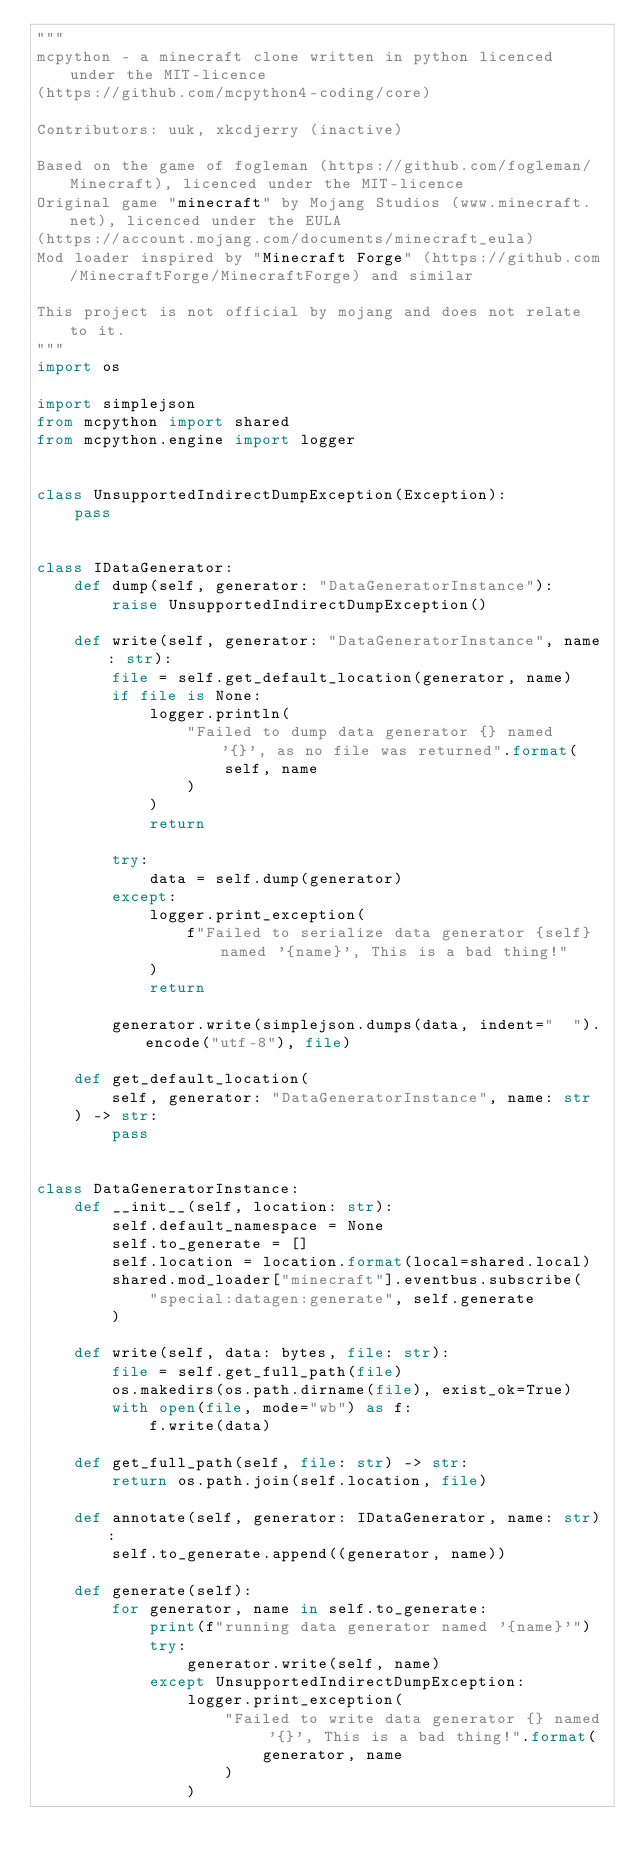<code> <loc_0><loc_0><loc_500><loc_500><_Python_>"""
mcpython - a minecraft clone written in python licenced under the MIT-licence 
(https://github.com/mcpython4-coding/core)

Contributors: uuk, xkcdjerry (inactive)

Based on the game of fogleman (https://github.com/fogleman/Minecraft), licenced under the MIT-licence
Original game "minecraft" by Mojang Studios (www.minecraft.net), licenced under the EULA
(https://account.mojang.com/documents/minecraft_eula)
Mod loader inspired by "Minecraft Forge" (https://github.com/MinecraftForge/MinecraftForge) and similar

This project is not official by mojang and does not relate to it.
"""
import os

import simplejson
from mcpython import shared
from mcpython.engine import logger


class UnsupportedIndirectDumpException(Exception):
    pass


class IDataGenerator:
    def dump(self, generator: "DataGeneratorInstance"):
        raise UnsupportedIndirectDumpException()

    def write(self, generator: "DataGeneratorInstance", name: str):
        file = self.get_default_location(generator, name)
        if file is None:
            logger.println(
                "Failed to dump data generator {} named '{}', as no file was returned".format(
                    self, name
                )
            )
            return

        try:
            data = self.dump(generator)
        except:
            logger.print_exception(
                f"Failed to serialize data generator {self} named '{name}', This is a bad thing!"
            )
            return

        generator.write(simplejson.dumps(data, indent="  ").encode("utf-8"), file)

    def get_default_location(
        self, generator: "DataGeneratorInstance", name: str
    ) -> str:
        pass


class DataGeneratorInstance:
    def __init__(self, location: str):
        self.default_namespace = None
        self.to_generate = []
        self.location = location.format(local=shared.local)
        shared.mod_loader["minecraft"].eventbus.subscribe(
            "special:datagen:generate", self.generate
        )

    def write(self, data: bytes, file: str):
        file = self.get_full_path(file)
        os.makedirs(os.path.dirname(file), exist_ok=True)
        with open(file, mode="wb") as f:
            f.write(data)

    def get_full_path(self, file: str) -> str:
        return os.path.join(self.location, file)

    def annotate(self, generator: IDataGenerator, name: str):
        self.to_generate.append((generator, name))

    def generate(self):
        for generator, name in self.to_generate:
            print(f"running data generator named '{name}'")
            try:
                generator.write(self, name)
            except UnsupportedIndirectDumpException:
                logger.print_exception(
                    "Failed to write data generator {} named '{}', This is a bad thing!".format(
                        generator, name
                    )
                )
</code> 